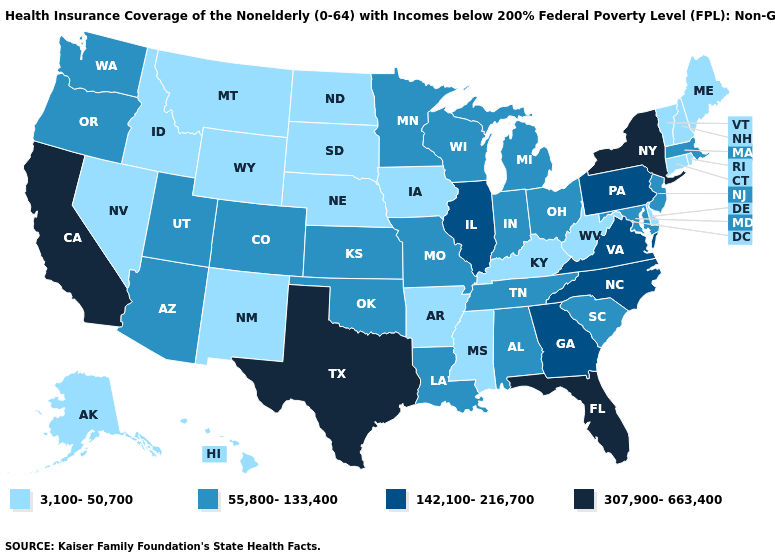What is the value of New York?
Concise answer only. 307,900-663,400. Does Missouri have the lowest value in the USA?
Concise answer only. No. Does the first symbol in the legend represent the smallest category?
Quick response, please. Yes. Does Arizona have a lower value than Maine?
Be succinct. No. Name the states that have a value in the range 142,100-216,700?
Give a very brief answer. Georgia, Illinois, North Carolina, Pennsylvania, Virginia. What is the lowest value in the Northeast?
Write a very short answer. 3,100-50,700. What is the value of Hawaii?
Give a very brief answer. 3,100-50,700. Does Washington have the same value as Ohio?
Short answer required. Yes. What is the value of Rhode Island?
Keep it brief. 3,100-50,700. Name the states that have a value in the range 142,100-216,700?
Write a very short answer. Georgia, Illinois, North Carolina, Pennsylvania, Virginia. What is the lowest value in the USA?
Be succinct. 3,100-50,700. What is the lowest value in the Northeast?
Keep it brief. 3,100-50,700. Which states have the lowest value in the West?
Answer briefly. Alaska, Hawaii, Idaho, Montana, Nevada, New Mexico, Wyoming. What is the value of Georgia?
Answer briefly. 142,100-216,700. What is the lowest value in states that border Arkansas?
Short answer required. 3,100-50,700. 